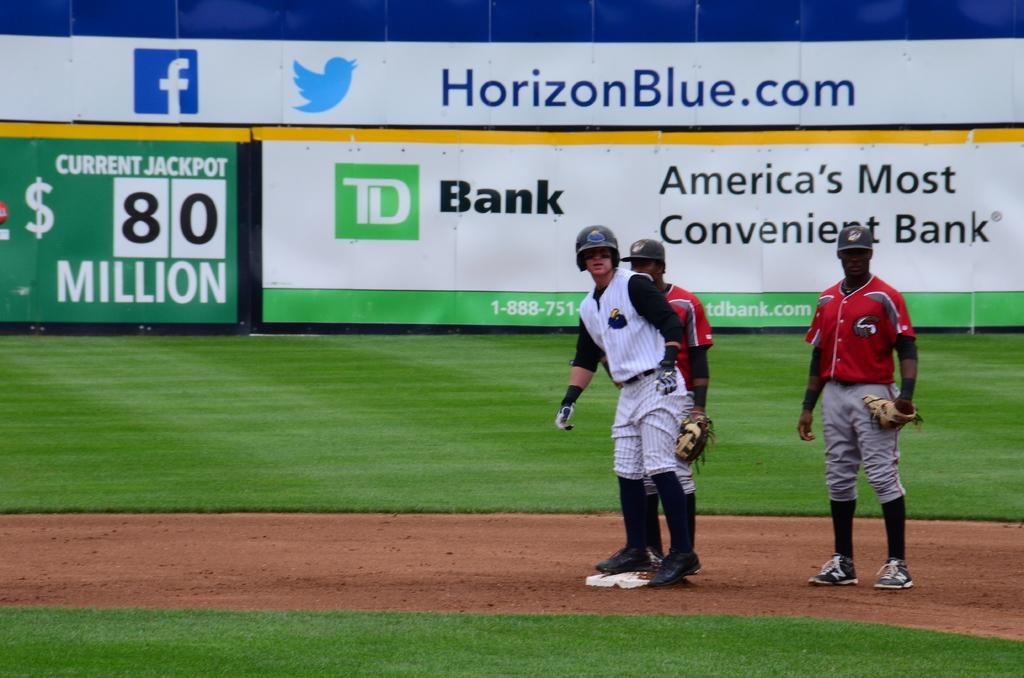<image>
Write a terse but informative summary of the picture. a player playing baseball with a horizonblue.com ad in the back 